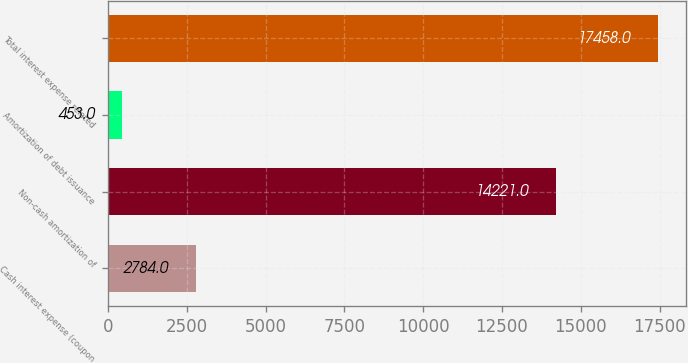Convert chart to OTSL. <chart><loc_0><loc_0><loc_500><loc_500><bar_chart><fcel>Cash interest expense (coupon<fcel>Non-cash amortization of<fcel>Amortization of debt issuance<fcel>Total interest expense related<nl><fcel>2784<fcel>14221<fcel>453<fcel>17458<nl></chart> 